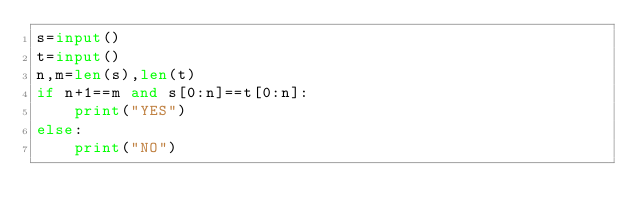<code> <loc_0><loc_0><loc_500><loc_500><_Python_>s=input()
t=input()
n,m=len(s),len(t)
if n+1==m and s[0:n]==t[0:n]:
    print("YES")
else:
    print("NO")
    

    
</code> 